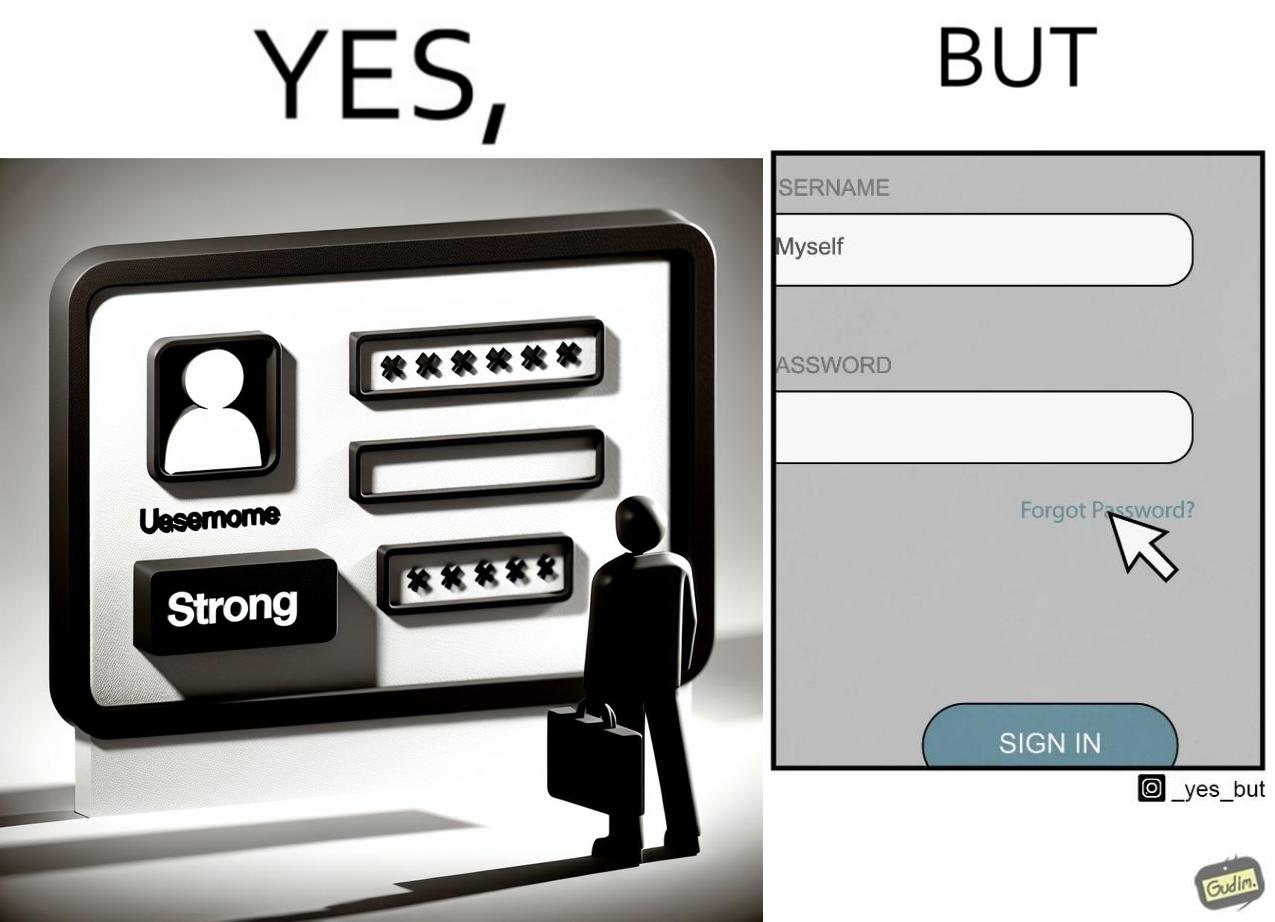Describe the satirical element in this image. The image is ironic, because people set such a strong passwords for their accounts that they even forget the password and need to reset them 